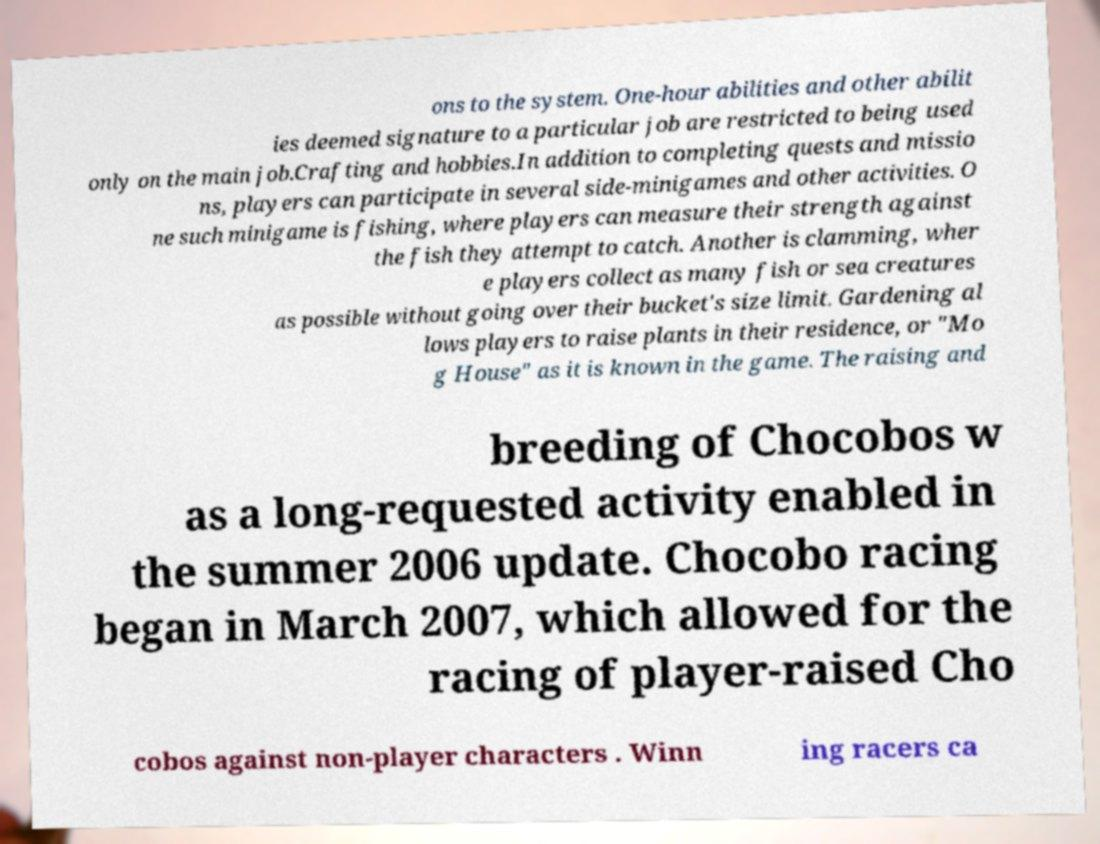Can you accurately transcribe the text from the provided image for me? ons to the system. One-hour abilities and other abilit ies deemed signature to a particular job are restricted to being used only on the main job.Crafting and hobbies.In addition to completing quests and missio ns, players can participate in several side-minigames and other activities. O ne such minigame is fishing, where players can measure their strength against the fish they attempt to catch. Another is clamming, wher e players collect as many fish or sea creatures as possible without going over their bucket's size limit. Gardening al lows players to raise plants in their residence, or "Mo g House" as it is known in the game. The raising and breeding of Chocobos w as a long-requested activity enabled in the summer 2006 update. Chocobo racing began in March 2007, which allowed for the racing of player-raised Cho cobos against non-player characters . Winn ing racers ca 